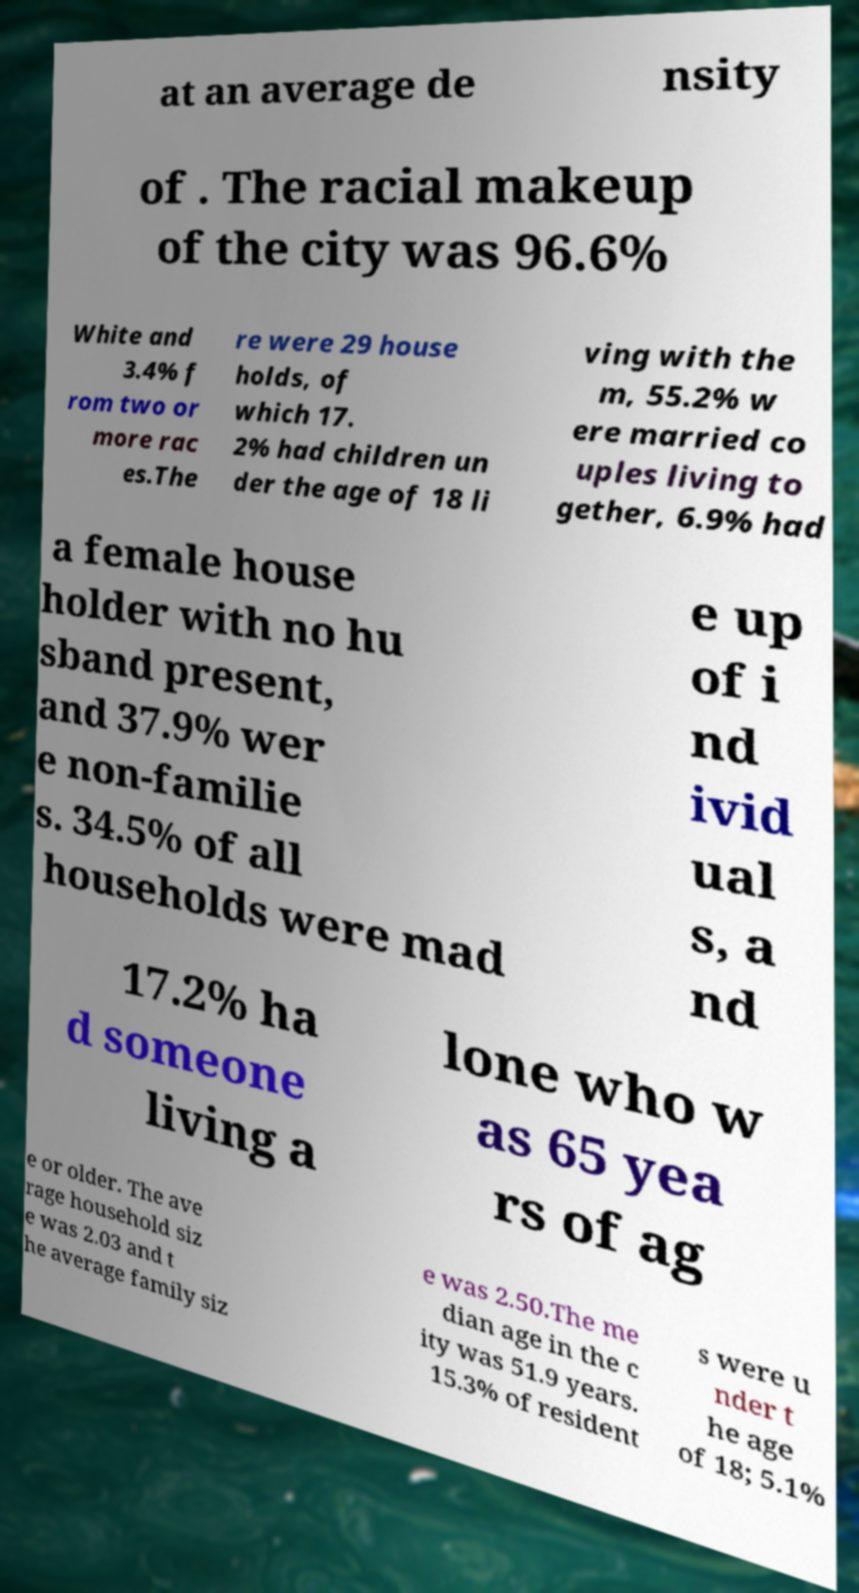Can you accurately transcribe the text from the provided image for me? at an average de nsity of . The racial makeup of the city was 96.6% White and 3.4% f rom two or more rac es.The re were 29 house holds, of which 17. 2% had children un der the age of 18 li ving with the m, 55.2% w ere married co uples living to gether, 6.9% had a female house holder with no hu sband present, and 37.9% wer e non-familie s. 34.5% of all households were mad e up of i nd ivid ual s, a nd 17.2% ha d someone living a lone who w as 65 yea rs of ag e or older. The ave rage household siz e was 2.03 and t he average family siz e was 2.50.The me dian age in the c ity was 51.9 years. 15.3% of resident s were u nder t he age of 18; 5.1% 